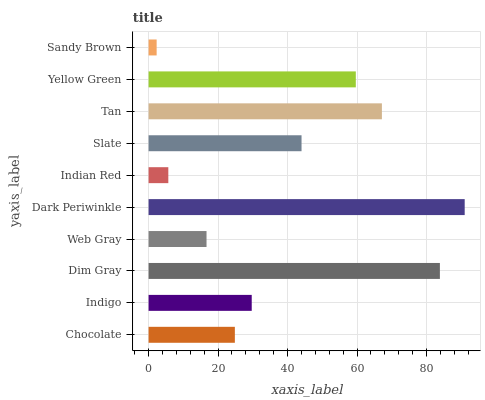Is Sandy Brown the minimum?
Answer yes or no. Yes. Is Dark Periwinkle the maximum?
Answer yes or no. Yes. Is Indigo the minimum?
Answer yes or no. No. Is Indigo the maximum?
Answer yes or no. No. Is Indigo greater than Chocolate?
Answer yes or no. Yes. Is Chocolate less than Indigo?
Answer yes or no. Yes. Is Chocolate greater than Indigo?
Answer yes or no. No. Is Indigo less than Chocolate?
Answer yes or no. No. Is Slate the high median?
Answer yes or no. Yes. Is Indigo the low median?
Answer yes or no. Yes. Is Indian Red the high median?
Answer yes or no. No. Is Web Gray the low median?
Answer yes or no. No. 